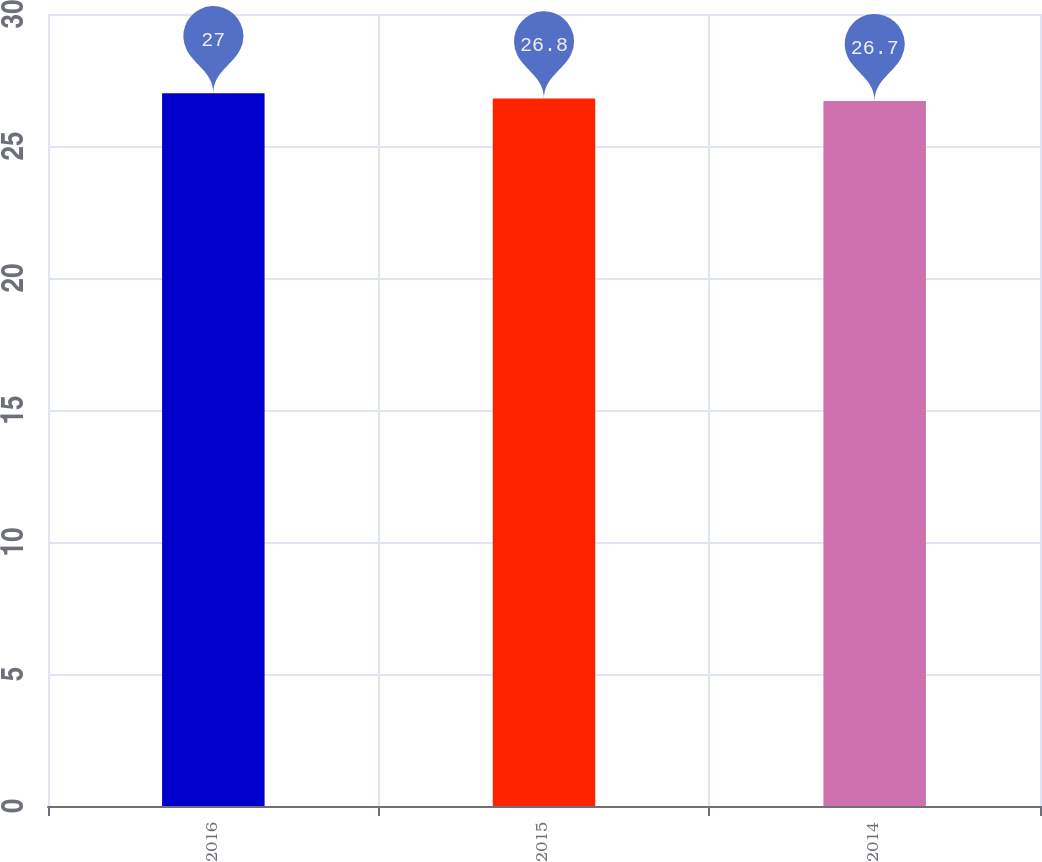<chart> <loc_0><loc_0><loc_500><loc_500><bar_chart><fcel>2016<fcel>2015<fcel>2014<nl><fcel>27<fcel>26.8<fcel>26.7<nl></chart> 